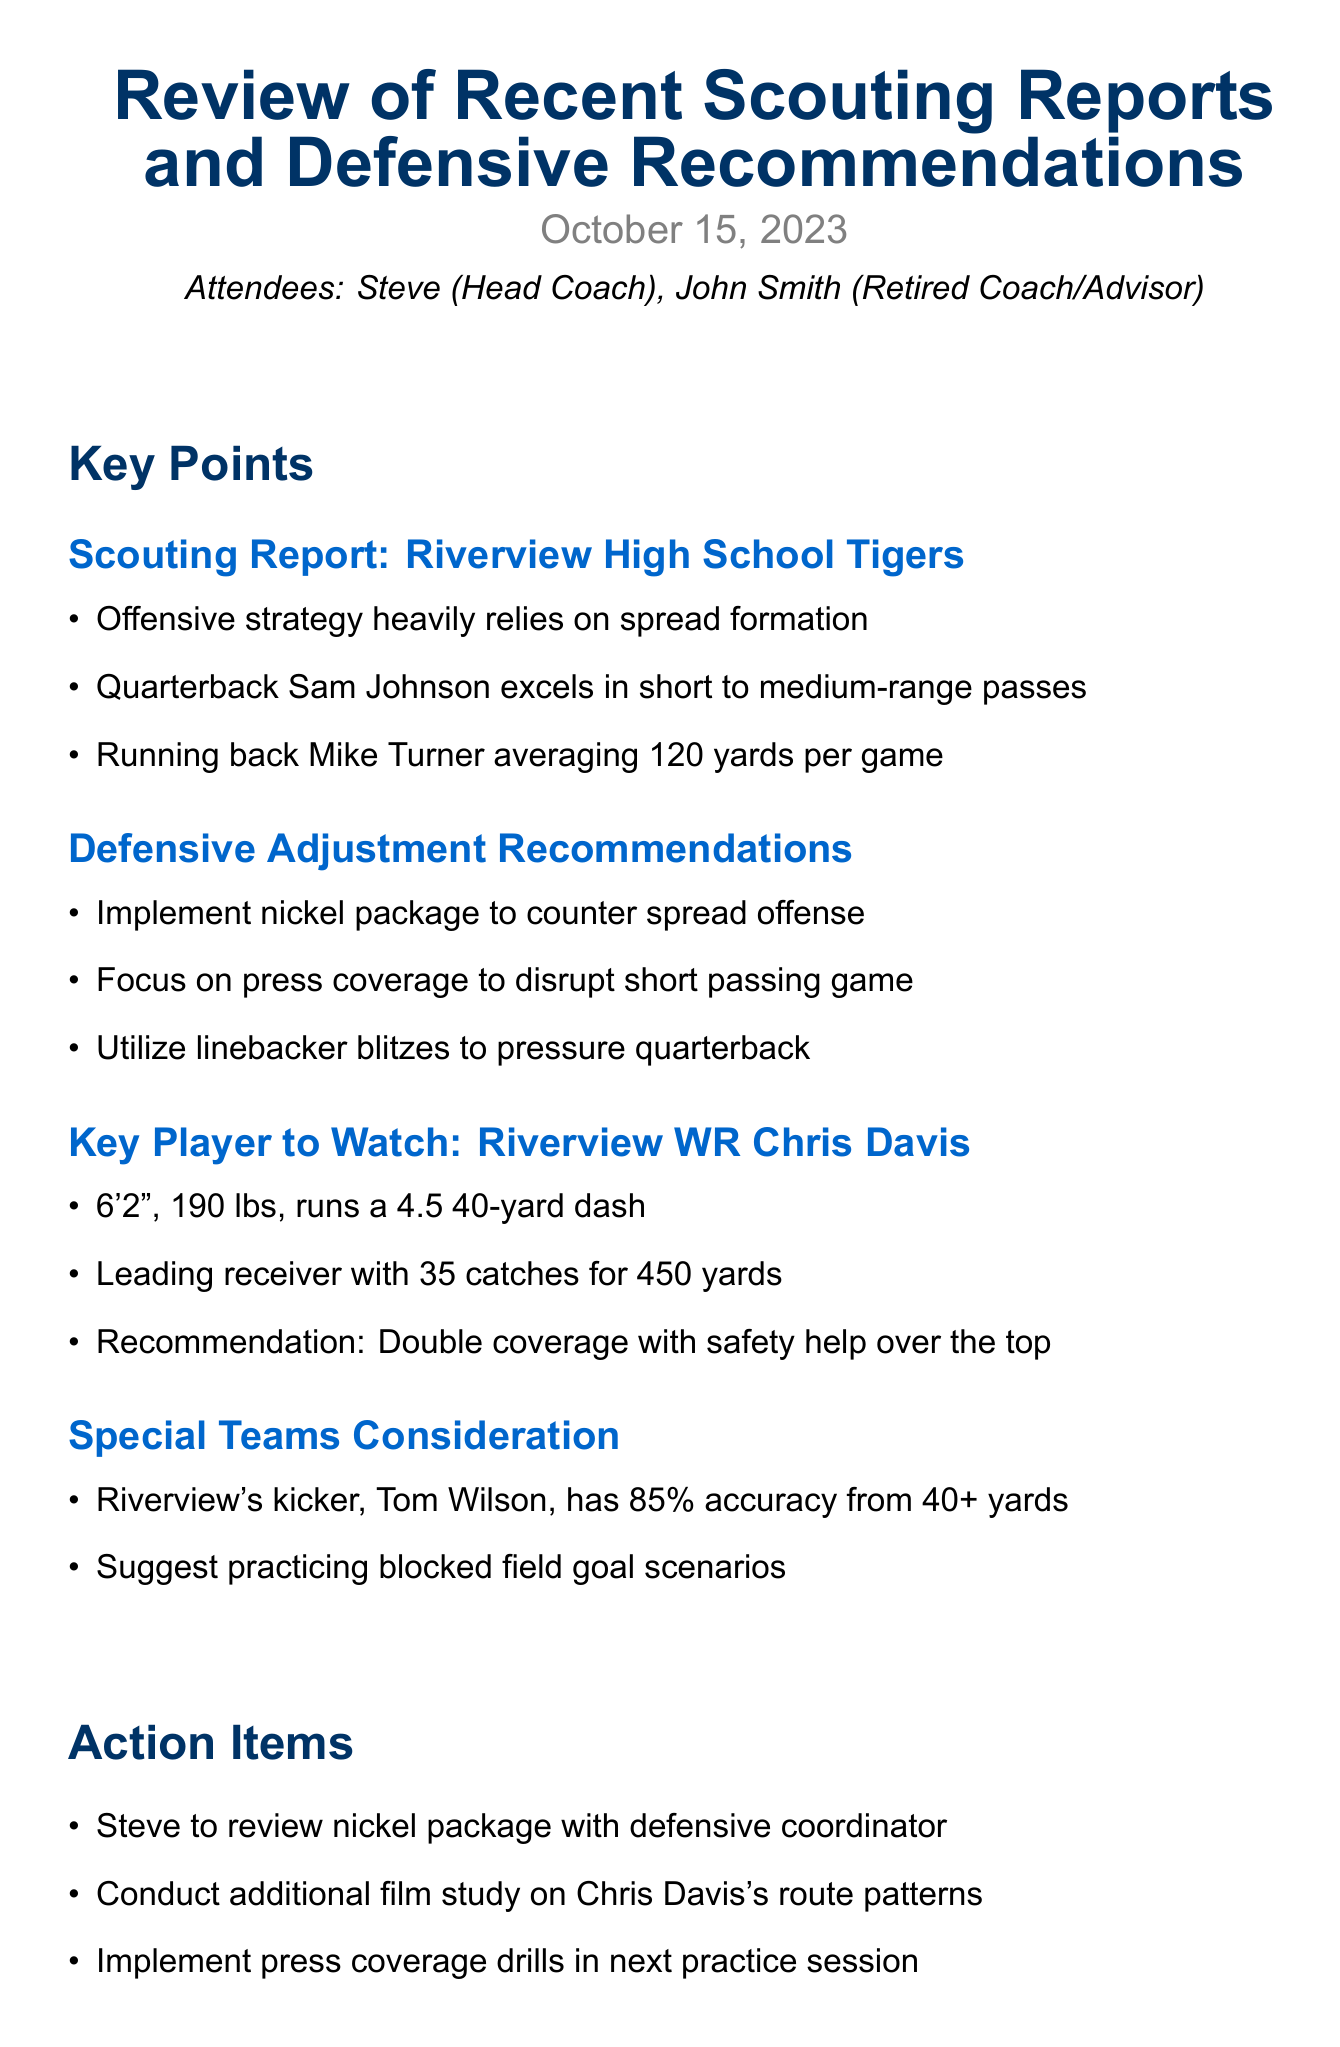What is the title of the meeting? The title is specified at the beginning of the document and is "Review of Recent Scouting Reports and Defensive Recommendations."
Answer: Review of Recent Scouting Reports and Defensive Recommendations Who is the leading receiver for Riverview? The document lists Chris Davis as the leading receiver along with his stats.
Answer: Chris Davis What is the average yardage per game for Riverview's running back? The report provides the average yardage directly associated with Mike Turner, the running back.
Answer: 120 yards What defensive package is recommended to counter the spread offense? The recommendations section states the type of package to implement for the specific strategy.
Answer: Nickel package How many catches does Chris Davis have? This information is provided in the key player section under his stats.
Answer: 35 catches What is the date of the next meeting? The next meeting date is clearly stated towards the end of the document.
Answer: October 22, 2023 What skill level does Riverview's kicker possess? The document states specific statistics about the kicker's performance, indicating his accuracy level.
Answer: 85% accuracy What action item relates to film study? The action items include a task specifically mentioning the film study of a player.
Answer: Conduct additional film study on Chris Davis's route patterns What is the primary recommendation for Chris Davis? The key player section includes a specific recommendation regarding his coverage.
Answer: Double coverage with safety help over the top 